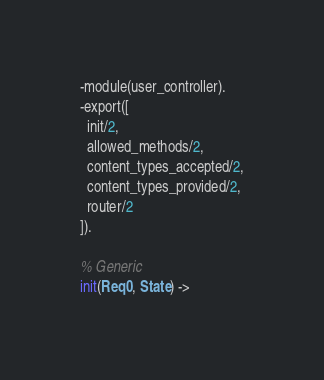Convert code to text. <code><loc_0><loc_0><loc_500><loc_500><_Erlang_>-module(user_controller).
-export([
  init/2,
  allowed_methods/2,
  content_types_accepted/2,
  content_types_provided/2,
  router/2
]).

% Generic
init(Req0, State) -></code> 